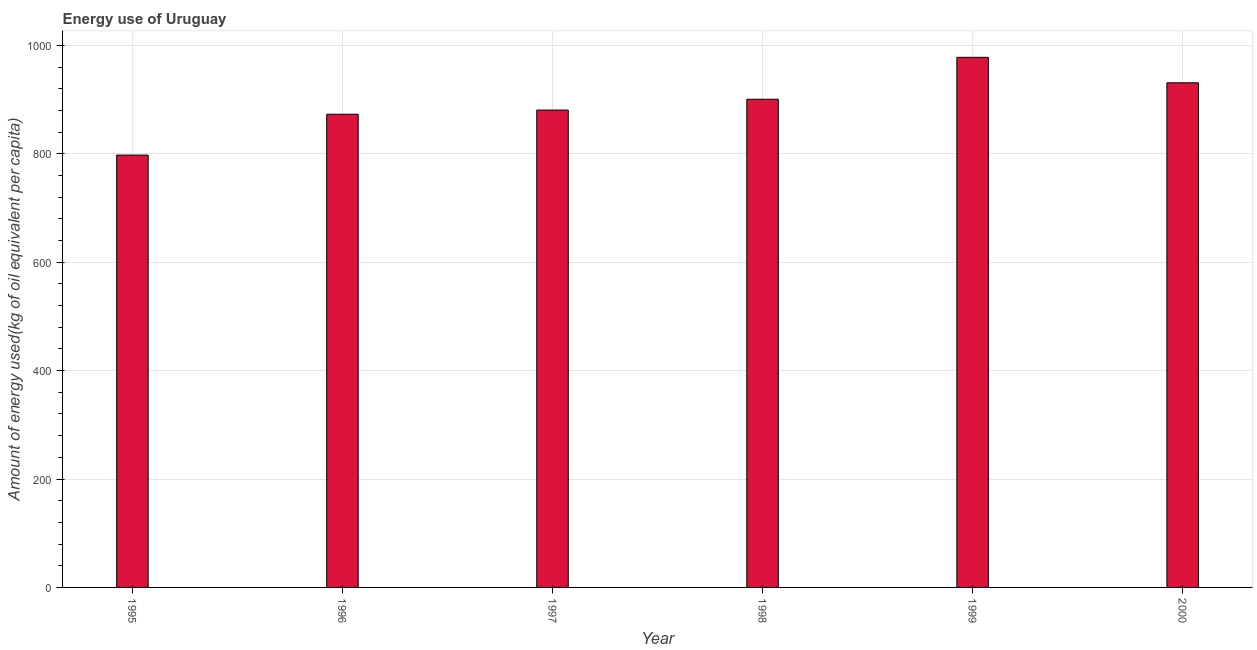Does the graph contain grids?
Offer a terse response. Yes. What is the title of the graph?
Offer a very short reply. Energy use of Uruguay. What is the label or title of the Y-axis?
Make the answer very short. Amount of energy used(kg of oil equivalent per capita). What is the amount of energy used in 1997?
Offer a terse response. 880.63. Across all years, what is the maximum amount of energy used?
Keep it short and to the point. 977.91. Across all years, what is the minimum amount of energy used?
Provide a short and direct response. 797.57. In which year was the amount of energy used maximum?
Your response must be concise. 1999. What is the sum of the amount of energy used?
Your response must be concise. 5360.54. What is the difference between the amount of energy used in 1996 and 1998?
Keep it short and to the point. -27.69. What is the average amount of energy used per year?
Offer a very short reply. 893.42. What is the median amount of energy used?
Give a very brief answer. 890.61. What is the ratio of the amount of energy used in 1997 to that in 1999?
Make the answer very short. 0.9. Is the amount of energy used in 1995 less than that in 1996?
Ensure brevity in your answer.  Yes. Is the difference between the amount of energy used in 1996 and 1999 greater than the difference between any two years?
Make the answer very short. No. What is the difference between the highest and the second highest amount of energy used?
Provide a succinct answer. 46.96. Is the sum of the amount of energy used in 1996 and 1999 greater than the maximum amount of energy used across all years?
Your response must be concise. Yes. What is the difference between the highest and the lowest amount of energy used?
Your answer should be compact. 180.34. Are all the bars in the graph horizontal?
Your response must be concise. No. What is the difference between two consecutive major ticks on the Y-axis?
Ensure brevity in your answer.  200. Are the values on the major ticks of Y-axis written in scientific E-notation?
Your response must be concise. No. What is the Amount of energy used(kg of oil equivalent per capita) of 1995?
Offer a very short reply. 797.57. What is the Amount of energy used(kg of oil equivalent per capita) of 1996?
Provide a short and direct response. 872.9. What is the Amount of energy used(kg of oil equivalent per capita) in 1997?
Your answer should be very brief. 880.63. What is the Amount of energy used(kg of oil equivalent per capita) of 1998?
Offer a very short reply. 900.59. What is the Amount of energy used(kg of oil equivalent per capita) in 1999?
Provide a succinct answer. 977.91. What is the Amount of energy used(kg of oil equivalent per capita) in 2000?
Ensure brevity in your answer.  930.94. What is the difference between the Amount of energy used(kg of oil equivalent per capita) in 1995 and 1996?
Ensure brevity in your answer.  -75.34. What is the difference between the Amount of energy used(kg of oil equivalent per capita) in 1995 and 1997?
Your answer should be compact. -83.07. What is the difference between the Amount of energy used(kg of oil equivalent per capita) in 1995 and 1998?
Keep it short and to the point. -103.02. What is the difference between the Amount of energy used(kg of oil equivalent per capita) in 1995 and 1999?
Provide a short and direct response. -180.34. What is the difference between the Amount of energy used(kg of oil equivalent per capita) in 1995 and 2000?
Provide a succinct answer. -133.38. What is the difference between the Amount of energy used(kg of oil equivalent per capita) in 1996 and 1997?
Offer a very short reply. -7.73. What is the difference between the Amount of energy used(kg of oil equivalent per capita) in 1996 and 1998?
Your response must be concise. -27.69. What is the difference between the Amount of energy used(kg of oil equivalent per capita) in 1996 and 1999?
Provide a short and direct response. -105. What is the difference between the Amount of energy used(kg of oil equivalent per capita) in 1996 and 2000?
Offer a terse response. -58.04. What is the difference between the Amount of energy used(kg of oil equivalent per capita) in 1997 and 1998?
Offer a terse response. -19.96. What is the difference between the Amount of energy used(kg of oil equivalent per capita) in 1997 and 1999?
Give a very brief answer. -97.27. What is the difference between the Amount of energy used(kg of oil equivalent per capita) in 1997 and 2000?
Offer a terse response. -50.31. What is the difference between the Amount of energy used(kg of oil equivalent per capita) in 1998 and 1999?
Provide a succinct answer. -77.32. What is the difference between the Amount of energy used(kg of oil equivalent per capita) in 1998 and 2000?
Your response must be concise. -30.35. What is the difference between the Amount of energy used(kg of oil equivalent per capita) in 1999 and 2000?
Your answer should be very brief. 46.96. What is the ratio of the Amount of energy used(kg of oil equivalent per capita) in 1995 to that in 1996?
Your answer should be very brief. 0.91. What is the ratio of the Amount of energy used(kg of oil equivalent per capita) in 1995 to that in 1997?
Offer a very short reply. 0.91. What is the ratio of the Amount of energy used(kg of oil equivalent per capita) in 1995 to that in 1998?
Keep it short and to the point. 0.89. What is the ratio of the Amount of energy used(kg of oil equivalent per capita) in 1995 to that in 1999?
Ensure brevity in your answer.  0.82. What is the ratio of the Amount of energy used(kg of oil equivalent per capita) in 1995 to that in 2000?
Your answer should be compact. 0.86. What is the ratio of the Amount of energy used(kg of oil equivalent per capita) in 1996 to that in 1997?
Keep it short and to the point. 0.99. What is the ratio of the Amount of energy used(kg of oil equivalent per capita) in 1996 to that in 1999?
Offer a terse response. 0.89. What is the ratio of the Amount of energy used(kg of oil equivalent per capita) in 1996 to that in 2000?
Your response must be concise. 0.94. What is the ratio of the Amount of energy used(kg of oil equivalent per capita) in 1997 to that in 1998?
Your answer should be very brief. 0.98. What is the ratio of the Amount of energy used(kg of oil equivalent per capita) in 1997 to that in 1999?
Make the answer very short. 0.9. What is the ratio of the Amount of energy used(kg of oil equivalent per capita) in 1997 to that in 2000?
Your answer should be very brief. 0.95. What is the ratio of the Amount of energy used(kg of oil equivalent per capita) in 1998 to that in 1999?
Offer a terse response. 0.92. What is the ratio of the Amount of energy used(kg of oil equivalent per capita) in 1999 to that in 2000?
Your response must be concise. 1.05. 